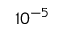Convert formula to latex. <formula><loc_0><loc_0><loc_500><loc_500>1 0 ^ { - 5 }</formula> 